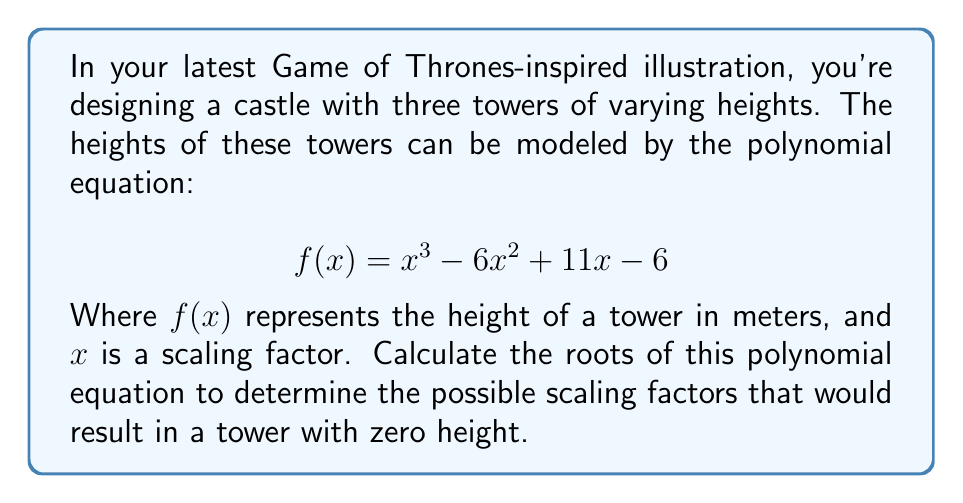What is the answer to this math problem? To find the roots of the polynomial equation, we need to solve:

$$ x^3 - 6x^2 + 11x - 6 = 0 $$

We can use the rational root theorem to find potential rational roots. The possible rational roots are the factors of the constant term (6): ±1, ±2, ±3, ±6.

Let's test these values:

1. For x = 1:
   $1^3 - 6(1)^2 + 11(1) - 6 = 1 - 6 + 11 - 6 = 0$
   
   We've found our first root: x = 1

2. Now we can factor out (x - 1):
   $x^3 - 6x^2 + 11x - 6 = (x - 1)(x^2 - 5x + 6)$

3. We can solve the quadratic equation $x^2 - 5x + 6 = 0$ using the quadratic formula:

   $x = \frac{-b \pm \sqrt{b^2 - 4ac}}{2a}$

   Where a = 1, b = -5, and c = 6

   $x = \frac{5 \pm \sqrt{25 - 24}}{2} = \frac{5 \pm 1}{2}$

4. This gives us two more roots:
   $x = \frac{5 + 1}{2} = 3$ and $x = \frac{5 - 1}{2} = 2$

Therefore, the roots of the polynomial equation are 1, 2, and 3.
Answer: The roots of the polynomial equation are x = 1, x = 2, and x = 3. 